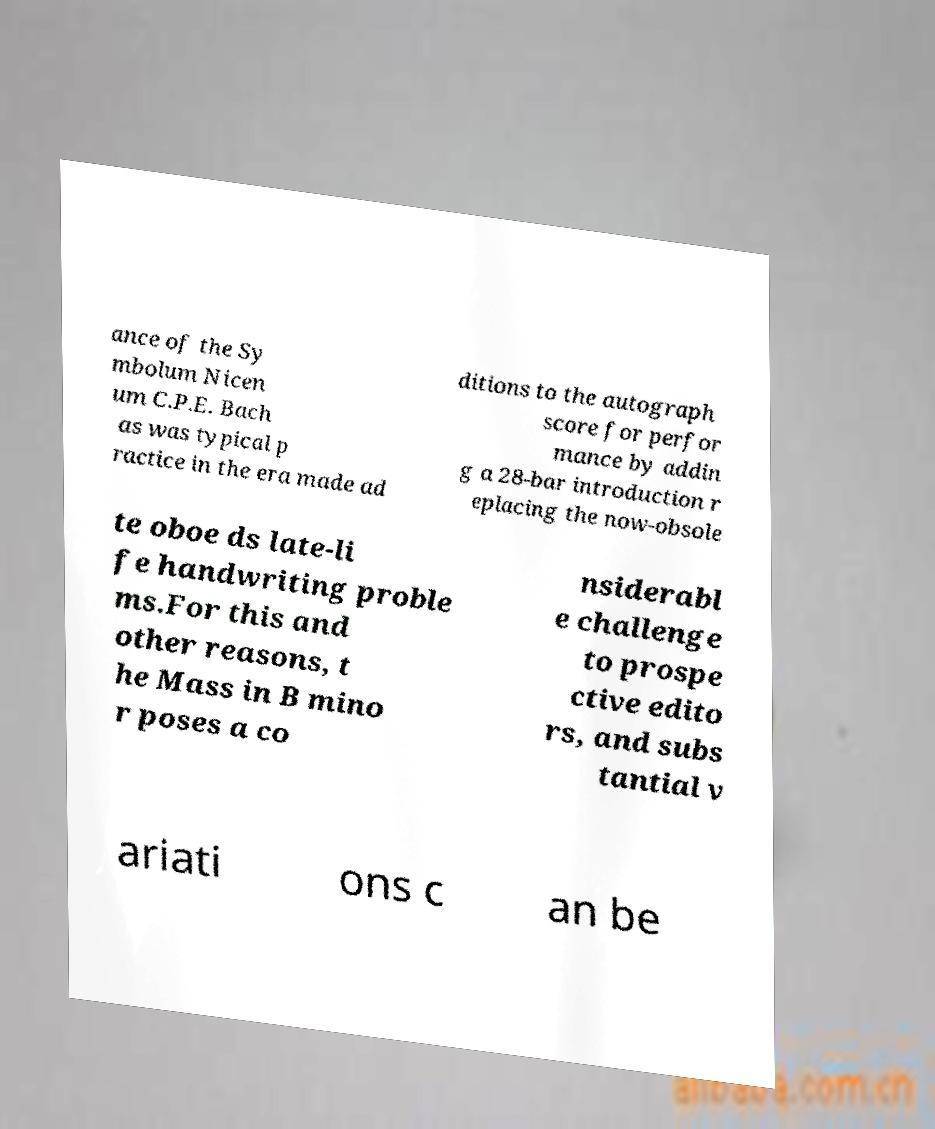Please identify and transcribe the text found in this image. ance of the Sy mbolum Nicen um C.P.E. Bach as was typical p ractice in the era made ad ditions to the autograph score for perfor mance by addin g a 28-bar introduction r eplacing the now-obsole te oboe ds late-li fe handwriting proble ms.For this and other reasons, t he Mass in B mino r poses a co nsiderabl e challenge to prospe ctive edito rs, and subs tantial v ariati ons c an be 